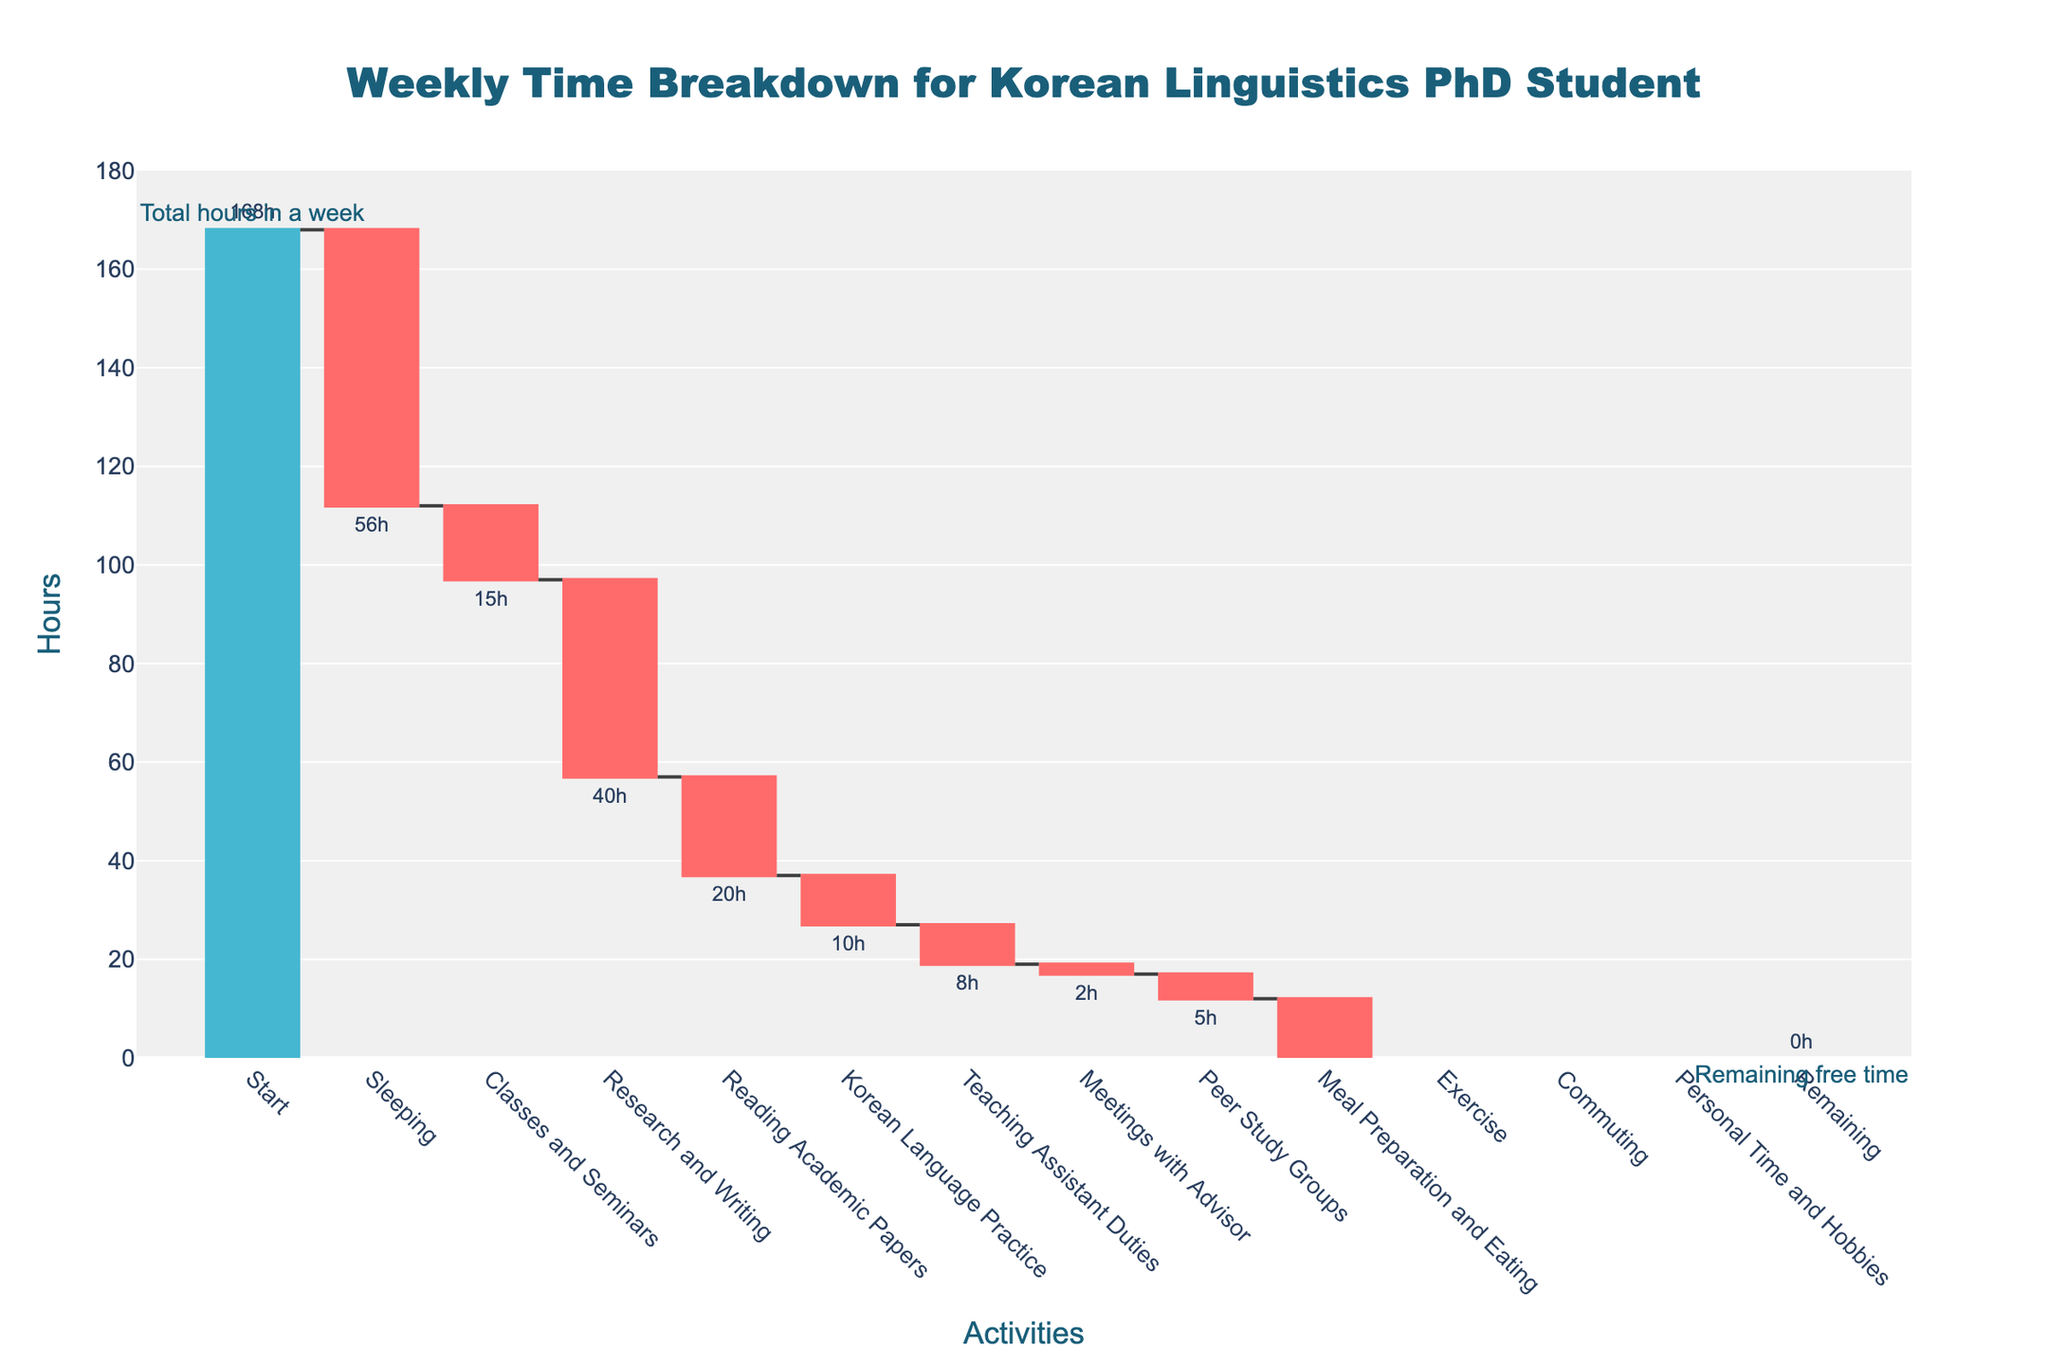What is the total number of hours in a week represented in the chart? The chart starts with the category "Start" positioned at 168 hours, indicating the total number of hours in a week.
Answer: 168 How many hours per week are spent on sleeping? The bar for "Sleeping" shows a negative value of 56 hours.
Answer: 56 What is the activity that takes the second most time after sleeping? After "Sleeping" with 56 hours, "Research and Writing" takes the next highest time with 40 hours, as indicated by the respective bars.
Answer: Research and Writing What is the total time spent on classes, research, and reading academic papers combined? To calculate the total time, sum the hours spent on "Classes and Seminars" (15), "Research and Writing" (40), and "Reading Academic Papers" (20). The sum is 15 + 40 + 20 = 75 hours.
Answer: 75 How much time is spent on activities related to the Korean language, including practice and academic reading? Sum the hours spent on "Reading Academic Papers" (20) and "Korean Language Practice" (10). The total is 20 + 10 = 30 hours.
Answer: 30 Which activity takes up the least amount of time per week? The bar for "Meetings with Advisor" has the smallest decrease, representing 2 hours.
Answer: Meetings with Advisor Compare the time spent on "Personal Time and Hobbies" and "Exercise". Which one is higher and by how many hours? The bar for "Personal Time and Hobbies" shows 8 hours, while the bar for "Exercise" shows 3 hours. The difference is 8 - 3 = 5 hours. Personal Time and Hobbies takes 5 more hours than Exercise.
Answer: Personal Time and Hobbies by 5 hours What is the total remaining free time at the end of the breakdown? The "Remaining" category is at the end of the chart with a bar reaching down to 0 hours.
Answer: 0 How many hours per week are spent commuting? The bar for "Commuting" shows a negative value of 5 hours.
Answer: 5 What is the average time spent per activity excluding "Start" and "Remaining"? Excluding "Start" and "Remaining", sum the hours of all activities (56 + 15 + 40 + 20 + 10 + 8 + 2 + 5 + 14 + 3 + 5 + 8 = 186) and divide by the number of activities (12). The average is 186 / 12 = 15.5 hours per activity.
Answer: 15.5 hours 